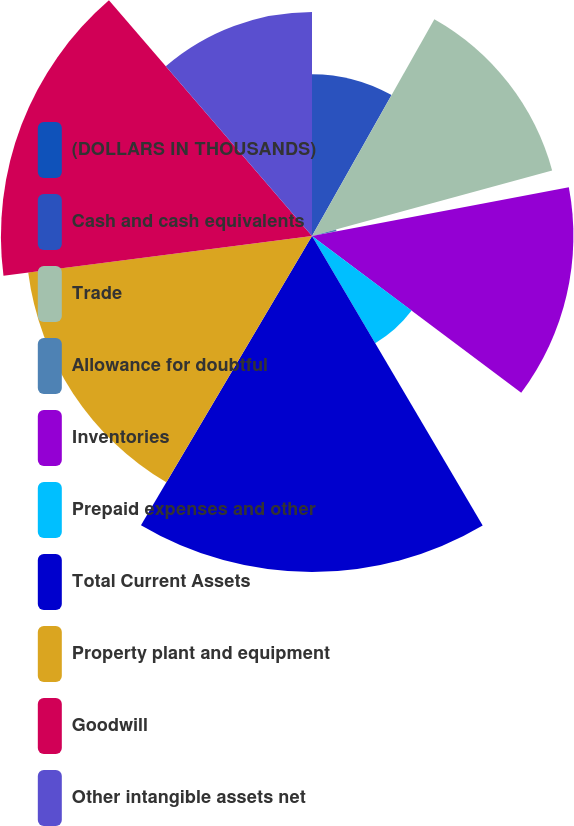Convert chart. <chart><loc_0><loc_0><loc_500><loc_500><pie_chart><fcel>(DOLLARS IN THOUSANDS)<fcel>Cash and cash equivalents<fcel>Trade<fcel>Allowance for doubtful<fcel>Inventories<fcel>Prepaid expenses and other<fcel>Total Current Assets<fcel>Property plant and equipment<fcel>Goodwill<fcel>Other intangible assets net<nl><fcel>0.0%<fcel>8.18%<fcel>12.58%<fcel>1.26%<fcel>13.21%<fcel>6.29%<fcel>16.98%<fcel>14.46%<fcel>15.72%<fcel>11.32%<nl></chart> 